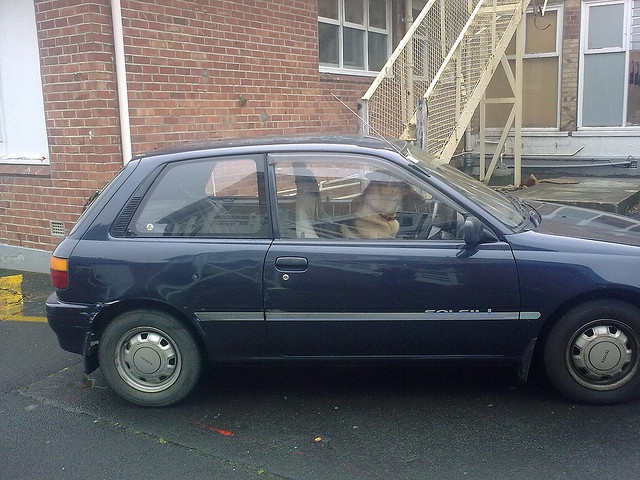Describe the objects in this image and their specific colors. I can see car in lightgray, black, gray, darkgray, and navy tones and dog in lightgray and gray tones in this image. 